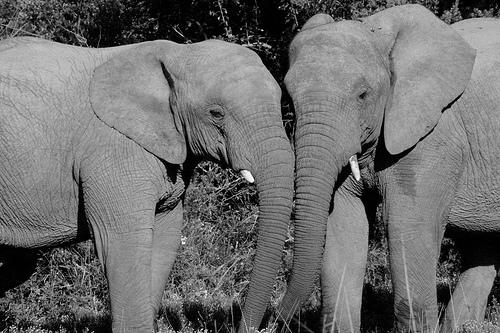Write a short story about what is happening in the image. In a serene landscape, two friendly elephants joyfully greet each other with their trunks, expressing love and companionship as nature surrounds them. State the primary action being performed in the image. Elephants touching noses and interacting affectionately. Describe the animals in the image and their notable features. Two adult gray elephants, one larger with big floppy ears and white tusks, the other smaller with little tusks, both featuring wrinkled hides and black eyes. Explain what's going on in the image in a single sentence. Two elephants are happily standing together, touching noses with trees and bushes in the background. Write a news headline based on the image. "Touching Moment: Two Elephants Share Affectionate Greeting in Natural Habitat" Provide a brief description of the primary elements within the image. Two gray adult elephants touching noses, with trees, bushes in the background, and various details such as eyes, ears, and tusks visible. Write a short, playful caption for the image. "Trunk Connection: Elephant Hugs and Nosey Greetings!" Write a brief description of the image, focusing on the surrounding environment. A peaceful setting with two happy elephants standing close, framed by trees, bushes, and the beauty of their natural surroundings. Write a poetic description of the scene in the image. Amidst a tranquil forest scene, two majestic elephants unite, their trunks entwined; a story of affection and kinship whispers through the leaves. Describe what the two main subjects in the image are doing, including any interactions. Two elephants are standing close together, seemingly trying to hug by touching noses and intertwining their trunks. 